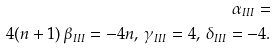<formula> <loc_0><loc_0><loc_500><loc_500>\alpha _ { I I I } = \\ 4 ( n + 1 ) \, \beta _ { I I I } = - 4 n , \, \gamma _ { I I I } = 4 , \, \delta _ { I I I } = - 4 .</formula> 